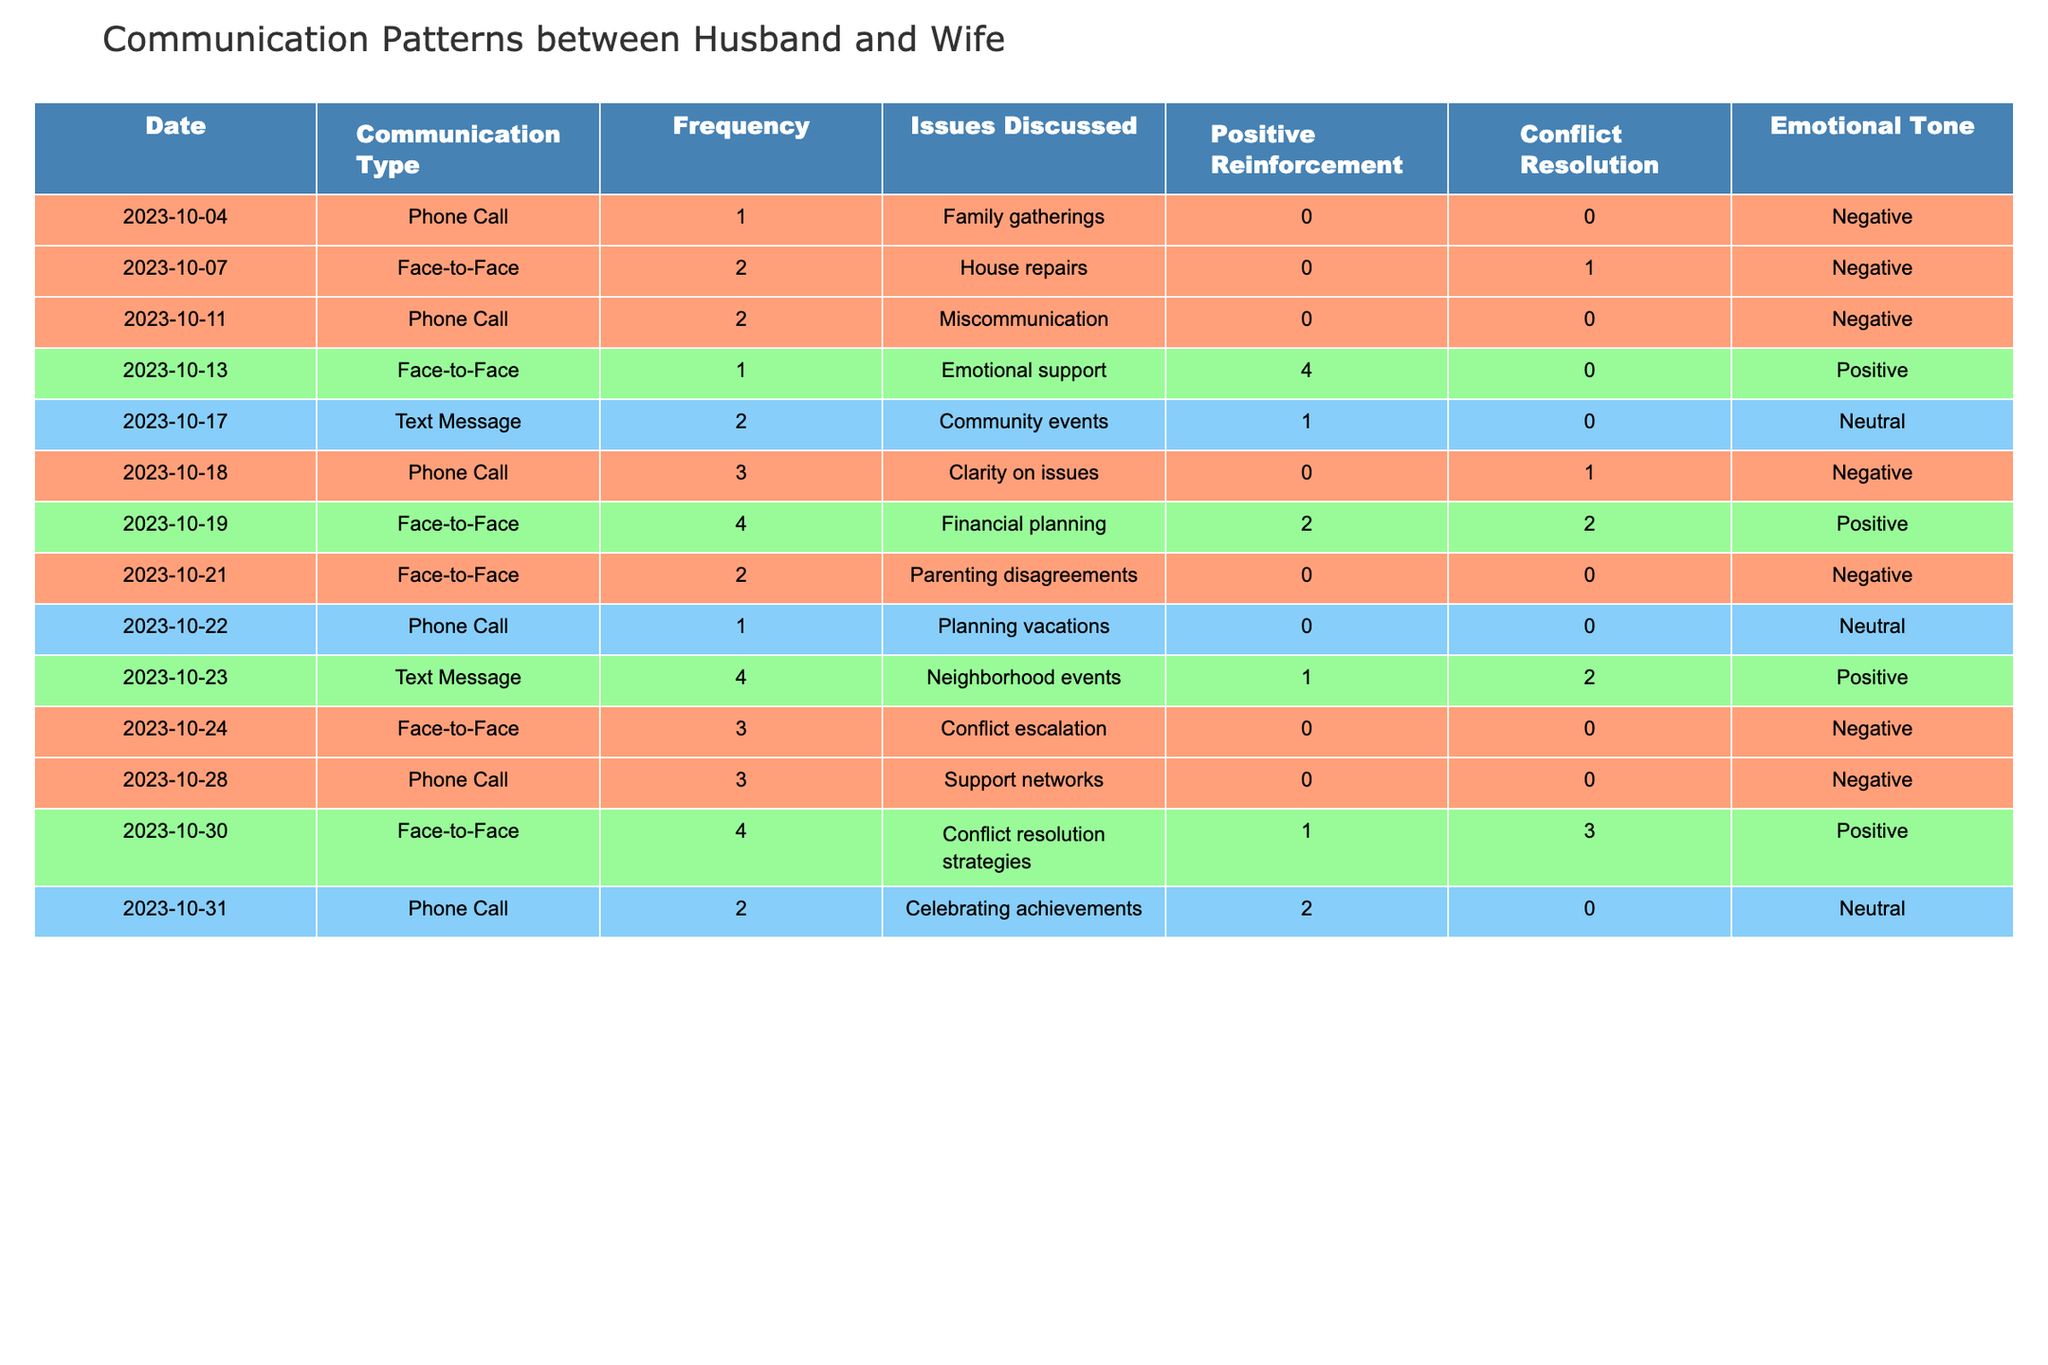What was the highest frequency of communication during the month? The highest frequency recorded is 4, which occurred on three different dates: October 19, October 23, and October 30.
Answer: 4 How many times did the couple communicate using phone calls? The couple had a total of 7 phone calls (1 + 2 + 3 + 1 + 3 + 2 = 12).
Answer: 12 On which date did the couple discuss the most issues? On October 19, they discussed 4 issues, which is the maximum recorded in the table.
Answer: October 19 Did they have any positive emotional tone during their communications? Yes, there were several instances of positive emotional tones, specifically on October 13, October 19, October 23, and October 30.
Answer: Yes What was the average frequency of communication for the month? The total frequency is 18 and dividing this by the number of communication sessions (12), gives an average of 1.5.
Answer: 1.5 How many instances contained conflict resolution discussions? There were 4 instances where conflict resolution was mentioned: on October 7, October 19, October 24, and October 30.
Answer: 4 What emotional tone was mostly associated with face-to-face communication? Out of the 6 face-to-face communications, 4 were negative, while only 2 were positive.
Answer: Negative Which communication type had the most positive reinforcement? Face-to-Face communication on October 19 had the highest positive reinforcement score of 2.
Answer: Face-to-Face Was there a date where negative emotional tone was associated with financial discussions? Yes, October 19 had a positive emotional tone despite discussing financial planning.
Answer: No Identify the day with the least communication frequency. The least communication frequency is 1, which occurred on October 4 and October 22.
Answer: October 4 and October 22 